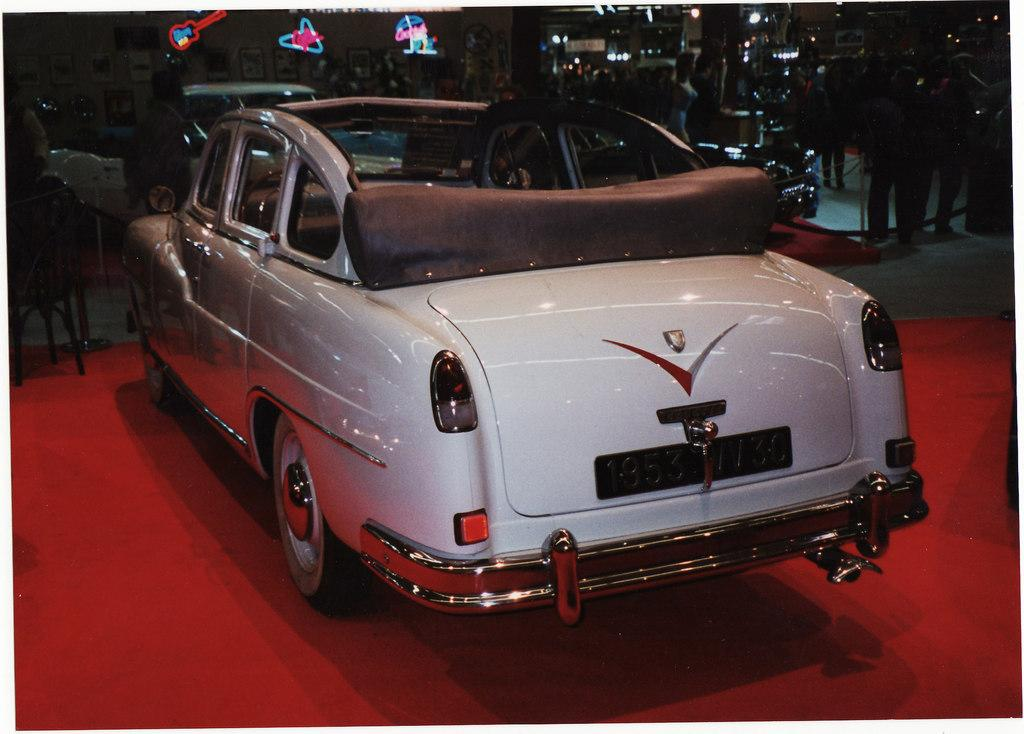What types of objects can be seen in the image? There are vehicles, poles and masts, people, frames on the wall, lights, and other objects visible in the image. Can you describe the vehicles in the image? The facts do not specify the type of vehicles, so we cannot describe them. What is the purpose of the poles and masts on the floor? The purpose of the poles and masts is not mentioned in the facts, so we cannot determine their purpose. What can be seen on the wall in the background? There are frames on the wall in the background. What is the source of illumination in the background? There are lights visible in the background. What type of table is used to store memories in the image? There is no table or mention of storing memories in the image. What kind of memory does the person in the image have about the event? The image does not provide any information about the person's memory or an event, so we cannot answer this question. 